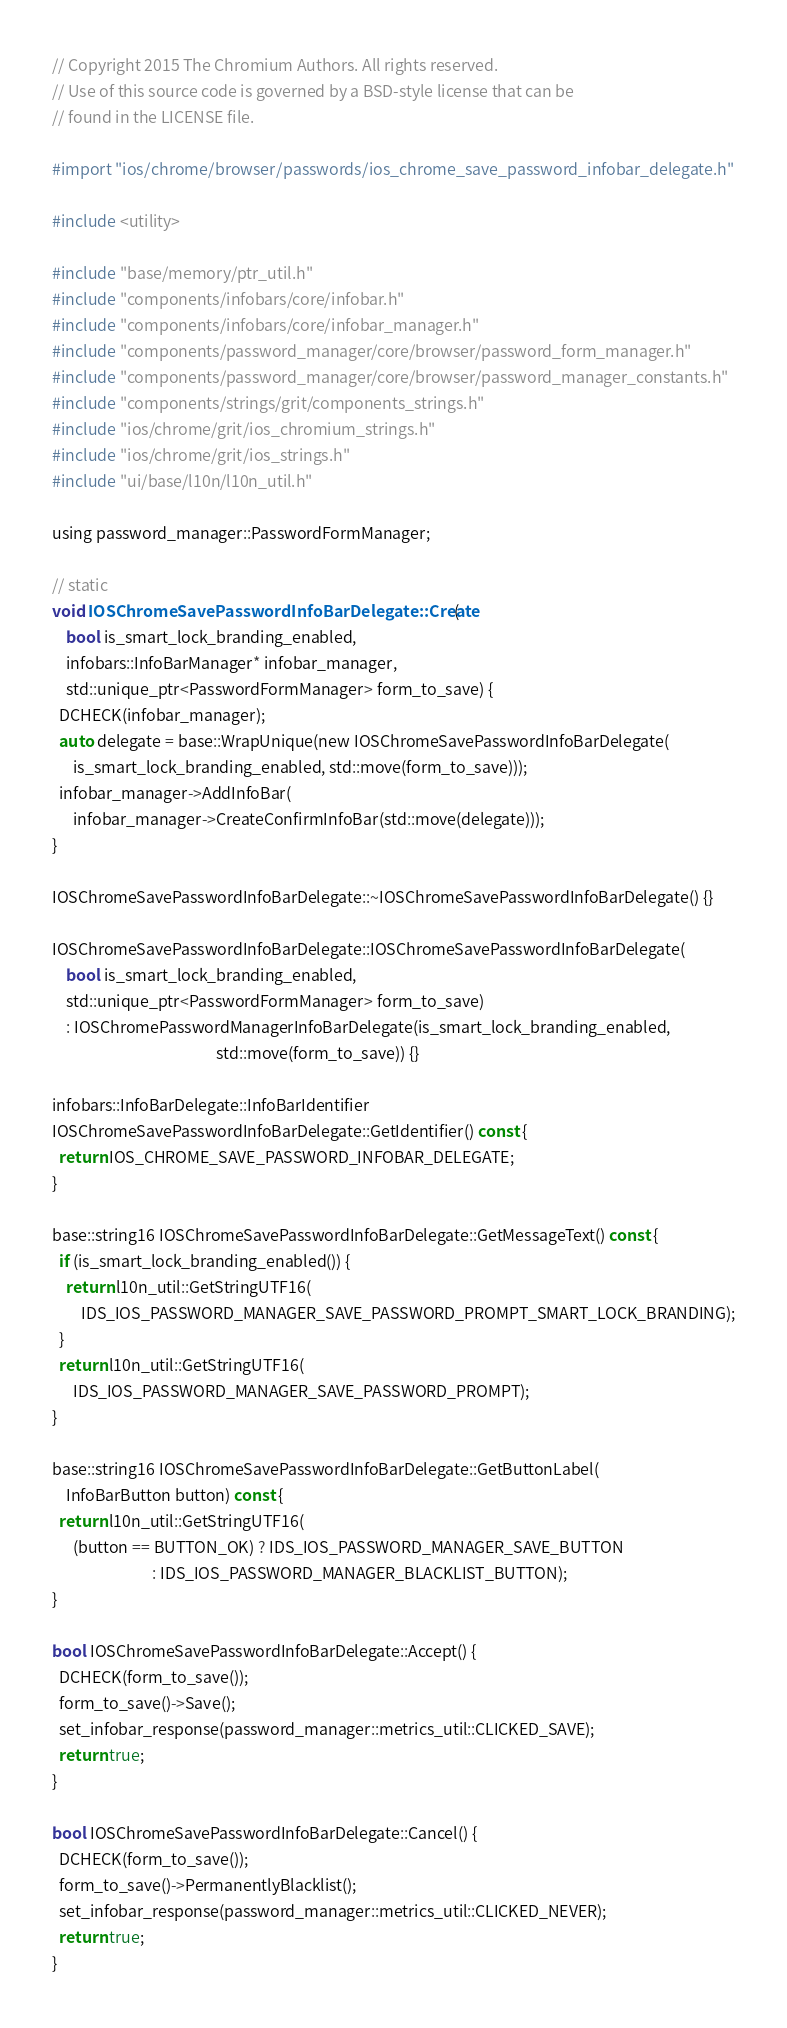Convert code to text. <code><loc_0><loc_0><loc_500><loc_500><_ObjectiveC_>// Copyright 2015 The Chromium Authors. All rights reserved.
// Use of this source code is governed by a BSD-style license that can be
// found in the LICENSE file.

#import "ios/chrome/browser/passwords/ios_chrome_save_password_infobar_delegate.h"

#include <utility>

#include "base/memory/ptr_util.h"
#include "components/infobars/core/infobar.h"
#include "components/infobars/core/infobar_manager.h"
#include "components/password_manager/core/browser/password_form_manager.h"
#include "components/password_manager/core/browser/password_manager_constants.h"
#include "components/strings/grit/components_strings.h"
#include "ios/chrome/grit/ios_chromium_strings.h"
#include "ios/chrome/grit/ios_strings.h"
#include "ui/base/l10n/l10n_util.h"

using password_manager::PasswordFormManager;

// static
void IOSChromeSavePasswordInfoBarDelegate::Create(
    bool is_smart_lock_branding_enabled,
    infobars::InfoBarManager* infobar_manager,
    std::unique_ptr<PasswordFormManager> form_to_save) {
  DCHECK(infobar_manager);
  auto delegate = base::WrapUnique(new IOSChromeSavePasswordInfoBarDelegate(
      is_smart_lock_branding_enabled, std::move(form_to_save)));
  infobar_manager->AddInfoBar(
      infobar_manager->CreateConfirmInfoBar(std::move(delegate)));
}

IOSChromeSavePasswordInfoBarDelegate::~IOSChromeSavePasswordInfoBarDelegate() {}

IOSChromeSavePasswordInfoBarDelegate::IOSChromeSavePasswordInfoBarDelegate(
    bool is_smart_lock_branding_enabled,
    std::unique_ptr<PasswordFormManager> form_to_save)
    : IOSChromePasswordManagerInfoBarDelegate(is_smart_lock_branding_enabled,
                                              std::move(form_to_save)) {}

infobars::InfoBarDelegate::InfoBarIdentifier
IOSChromeSavePasswordInfoBarDelegate::GetIdentifier() const {
  return IOS_CHROME_SAVE_PASSWORD_INFOBAR_DELEGATE;
}

base::string16 IOSChromeSavePasswordInfoBarDelegate::GetMessageText() const {
  if (is_smart_lock_branding_enabled()) {
    return l10n_util::GetStringUTF16(
        IDS_IOS_PASSWORD_MANAGER_SAVE_PASSWORD_PROMPT_SMART_LOCK_BRANDING);
  }
  return l10n_util::GetStringUTF16(
      IDS_IOS_PASSWORD_MANAGER_SAVE_PASSWORD_PROMPT);
}

base::string16 IOSChromeSavePasswordInfoBarDelegate::GetButtonLabel(
    InfoBarButton button) const {
  return l10n_util::GetStringUTF16(
      (button == BUTTON_OK) ? IDS_IOS_PASSWORD_MANAGER_SAVE_BUTTON
                            : IDS_IOS_PASSWORD_MANAGER_BLACKLIST_BUTTON);
}

bool IOSChromeSavePasswordInfoBarDelegate::Accept() {
  DCHECK(form_to_save());
  form_to_save()->Save();
  set_infobar_response(password_manager::metrics_util::CLICKED_SAVE);
  return true;
}

bool IOSChromeSavePasswordInfoBarDelegate::Cancel() {
  DCHECK(form_to_save());
  form_to_save()->PermanentlyBlacklist();
  set_infobar_response(password_manager::metrics_util::CLICKED_NEVER);
  return true;
}
</code> 